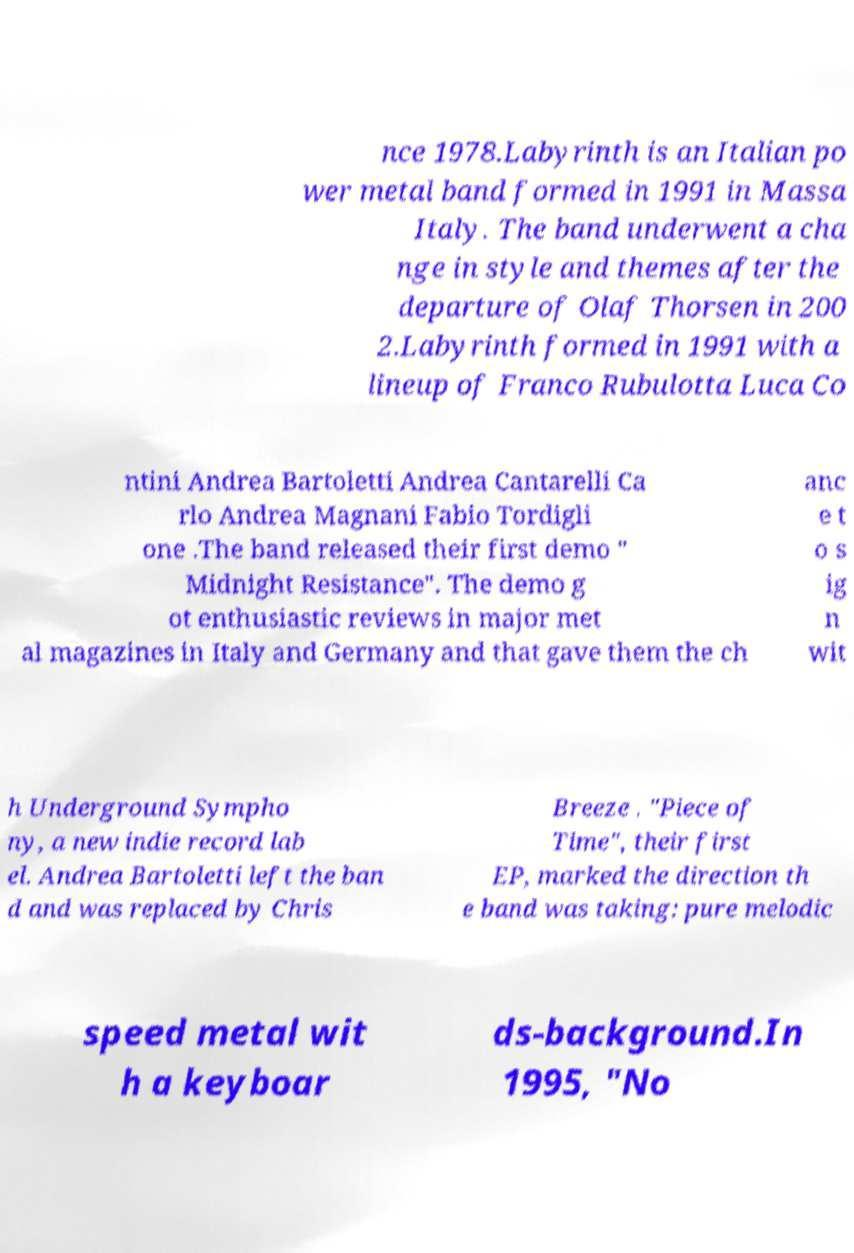I need the written content from this picture converted into text. Can you do that? nce 1978.Labyrinth is an Italian po wer metal band formed in 1991 in Massa Italy. The band underwent a cha nge in style and themes after the departure of Olaf Thorsen in 200 2.Labyrinth formed in 1991 with a lineup of Franco Rubulotta Luca Co ntini Andrea Bartoletti Andrea Cantarelli Ca rlo Andrea Magnani Fabio Tordigli one .The band released their first demo " Midnight Resistance". The demo g ot enthusiastic reviews in major met al magazines in Italy and Germany and that gave them the ch anc e t o s ig n wit h Underground Sympho ny, a new indie record lab el. Andrea Bartoletti left the ban d and was replaced by Chris Breeze . "Piece of Time", their first EP, marked the direction th e band was taking: pure melodic speed metal wit h a keyboar ds-background.In 1995, "No 